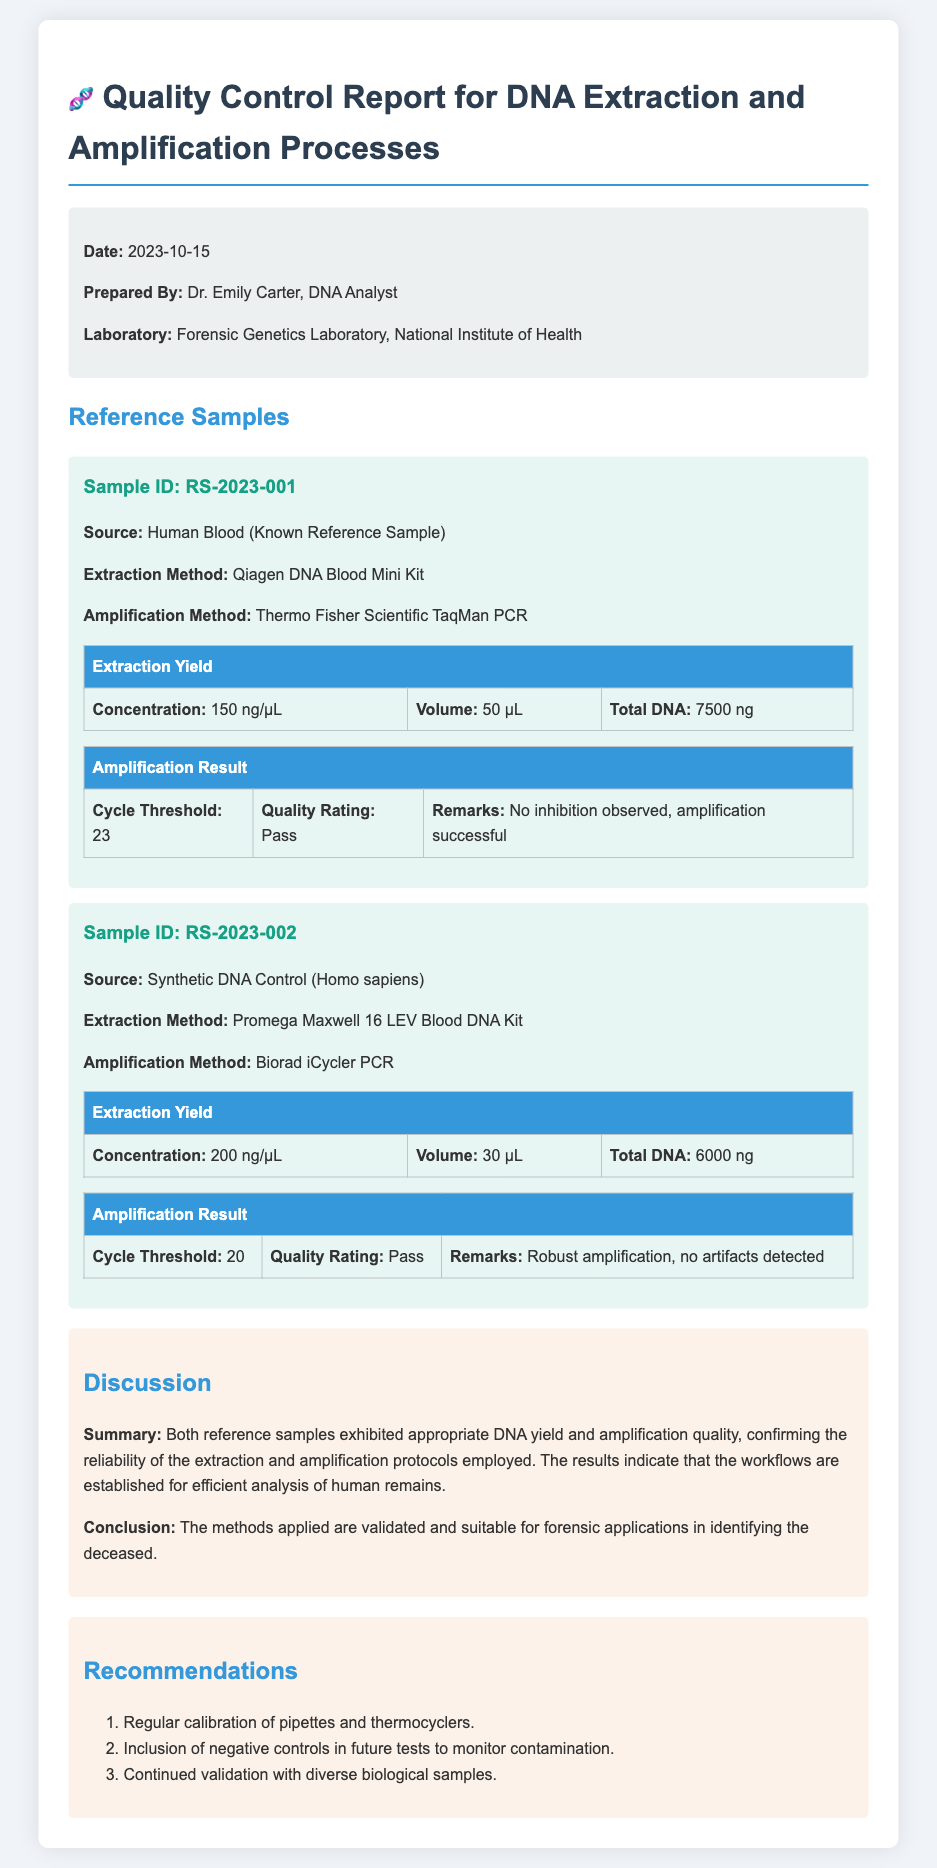what is the date of the report? The date of the report is explicitly stated in the meta-info section of the document.
Answer: 2023-10-15 who prepared the report? The report lists the name of the individual who prepared it under the meta-info section.
Answer: Dr. Emily Carter what is the source of Sample ID RS-2023-001? The source of this sample is mentioned in the sample description within the report.
Answer: Human Blood (Known Reference Sample) what is the total DNA extracted from Sample ID RS-2023-002? The total DNA is provided in the extraction yield table of the respective sample section.
Answer: 6000 ng how many recommendations are provided in the report? The number of recommendations is determined by counting the list items in the recommendations section.
Answer: 3 what was the cycle threshold for Sample ID RS-2023-001? The cycle threshold is outlined in the amplification result table for this specific sample.
Answer: 23 what is the quality rating for the amplification result of Sample ID RS-2023-002? The quality rating is provided in the amplification result table under this sample’s section.
Answer: Pass what extraction method was used for Sample ID RS-2023-001? The extraction method is included in the details of the sample description in the report.
Answer: Qiagen DNA Blood Mini Kit 